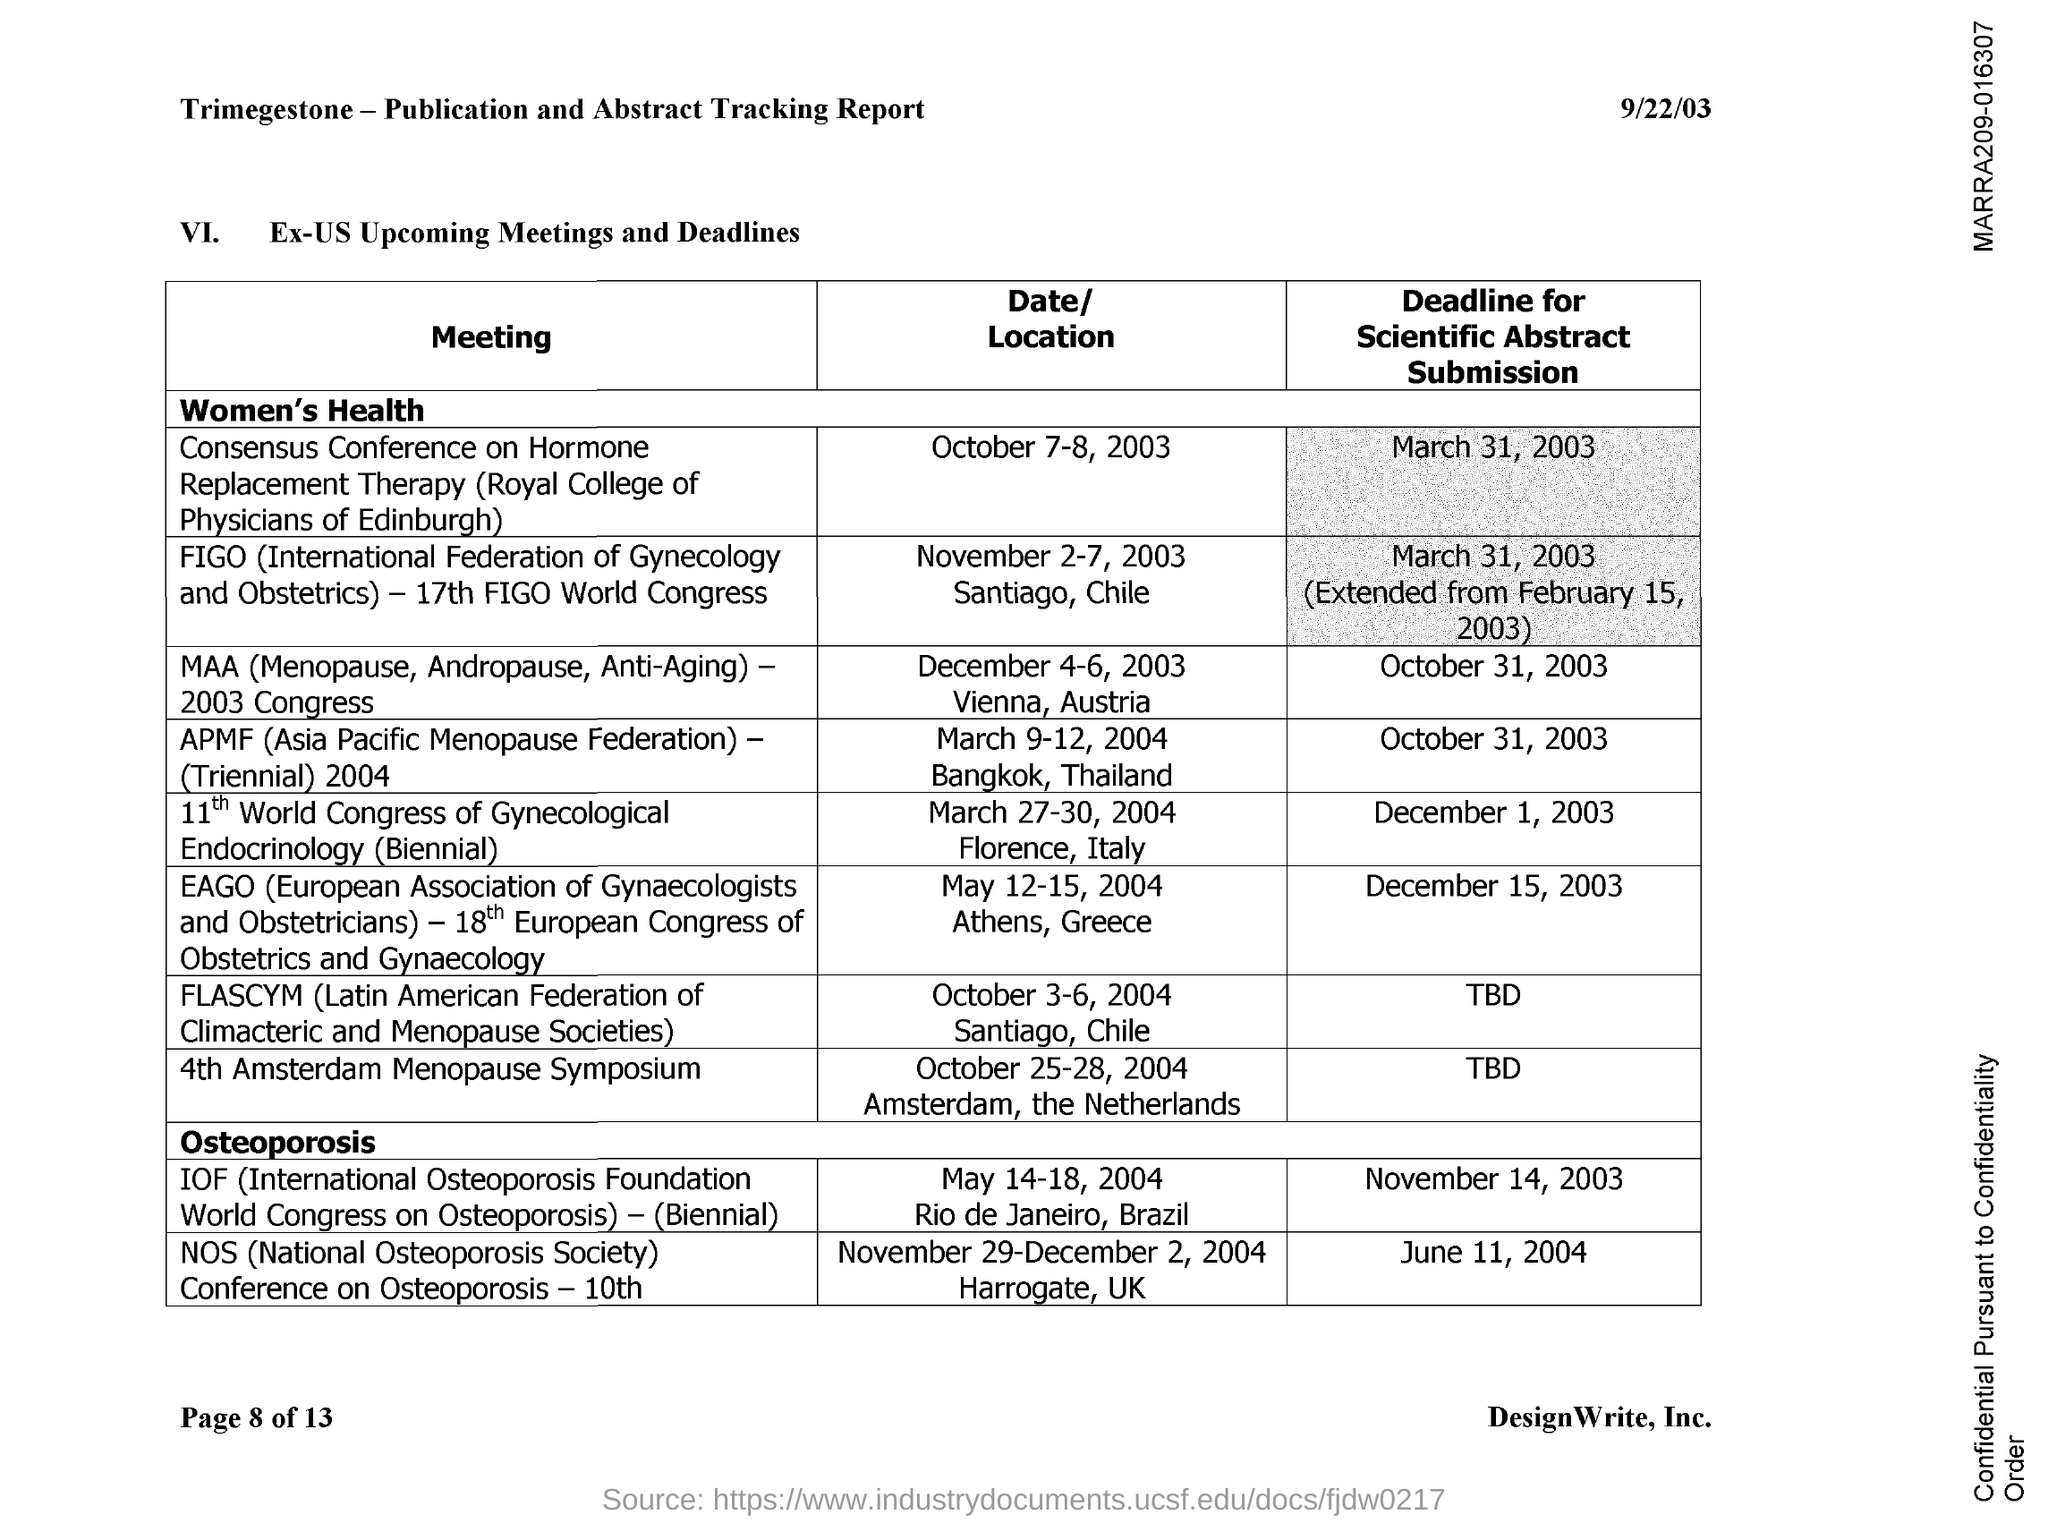What is the full form of NOS?
Ensure brevity in your answer.  National osteoporosis society. What is the full form of APMF?
Your response must be concise. Asia Pacific Menopause Federation. 